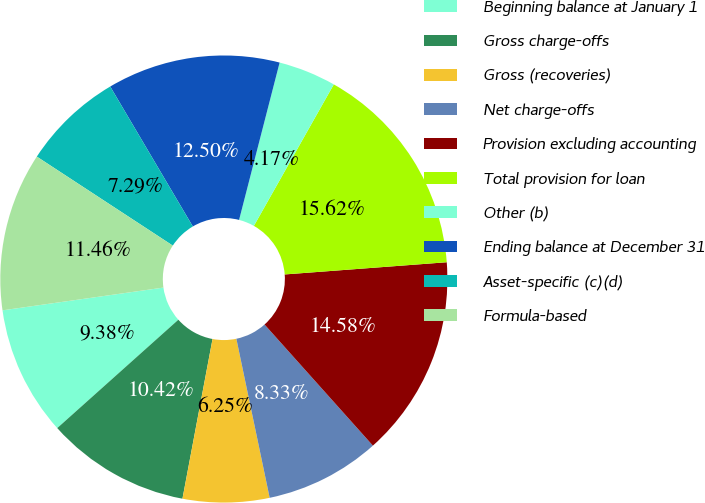Convert chart. <chart><loc_0><loc_0><loc_500><loc_500><pie_chart><fcel>Beginning balance at January 1<fcel>Gross charge-offs<fcel>Gross (recoveries)<fcel>Net charge-offs<fcel>Provision excluding accounting<fcel>Total provision for loan<fcel>Other (b)<fcel>Ending balance at December 31<fcel>Asset-specific (c)(d)<fcel>Formula-based<nl><fcel>9.38%<fcel>10.42%<fcel>6.25%<fcel>8.33%<fcel>14.58%<fcel>15.62%<fcel>4.17%<fcel>12.5%<fcel>7.29%<fcel>11.46%<nl></chart> 